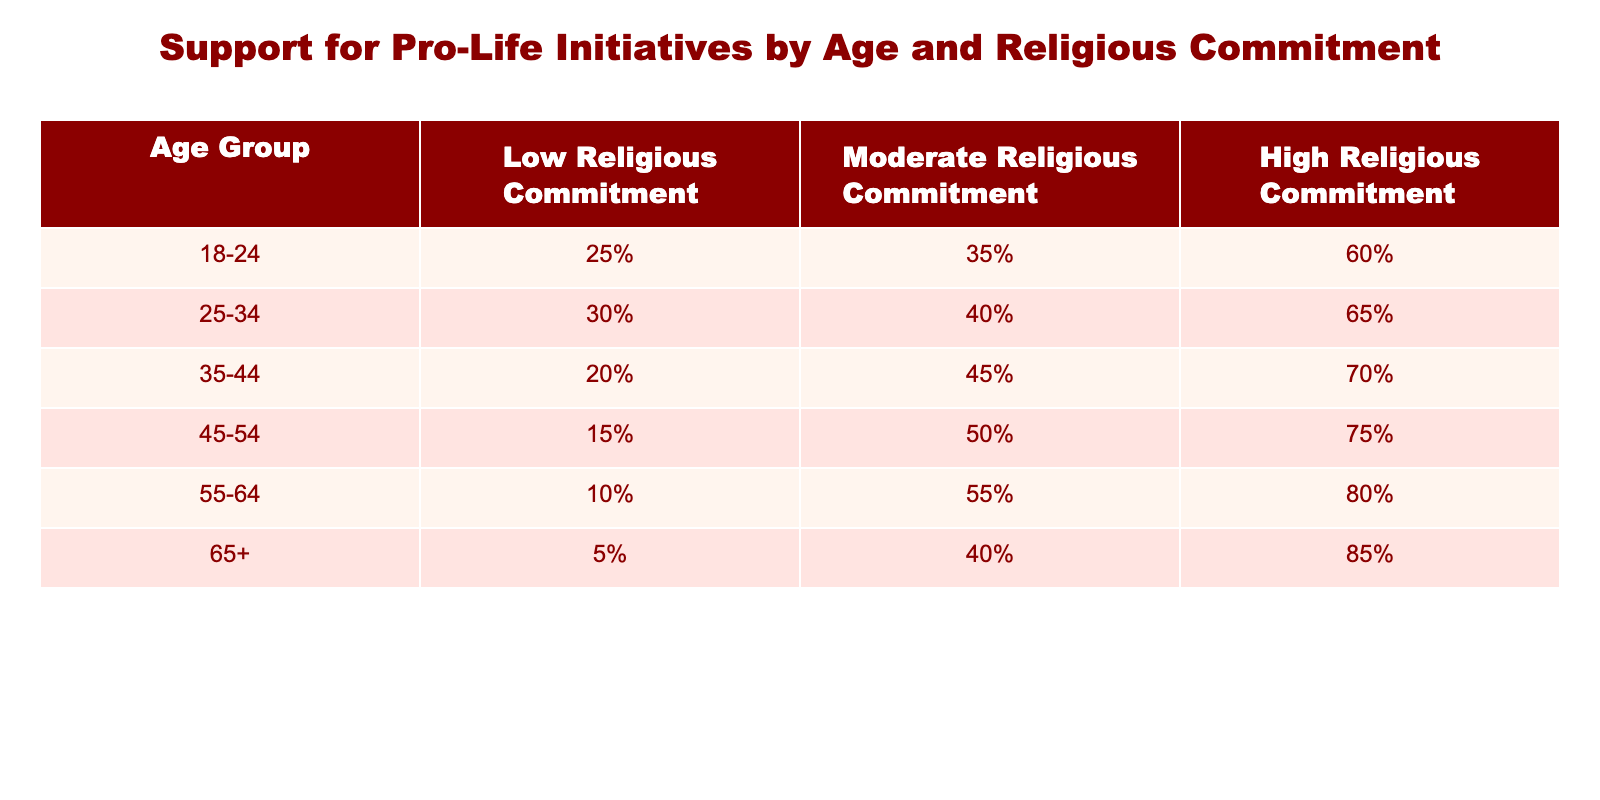What percentage of 18-24 year-olds with high religious commitment support pro-life initiatives? According to the table, the percentage of 18-24 year-olds with high religious commitment supporting pro-life initiatives is directly stated as 60%.
Answer: 60% What is the lowest percentage of support for pro-life initiatives among moderate religious commitment across all age groups? To find the lowest percentage in the column for moderate religious commitment, we look at each percentage: 35%, 40%, 45%, 50%, 55%, 40%. The lowest is 35% among the 18-24 age group.
Answer: 35% How many age groups have more than 50% support for pro-life initiatives among those with high religious commitment? We check the high religious commitment column for each age group: 60%, 65%, 70%, 75%, 80%, 85%. All have more than 50% support, making a total of five age groups.
Answer: 5 What is the average support for pro-life initiatives among the 55-64 age group regardless of religious commitment? The percentages for the 55-64 age group are 10%, 55%, and 80% for low, moderate, and high religious commitment, respectively. We take the average: (10 + 55 + 80) / 3 = 145 / 3 = 48.33%.
Answer: 48.33% Do more than half of the 45-54 age group with moderate religious commitment support pro-life initiatives? For the 45-54 age group under moderate religious commitment, the support is 50%. Since 50% is not more than half, the answer is no.
Answer: No How does the support for pro-life initiatives differ between the 25-34 and 35-44 age groups for those with moderate religious commitment? In the table, the 25-34 age group has 40% support while the 35-44 age group has 45% support under moderate religious commitment. The difference is 45% - 40% = 5%.
Answer: 5% 